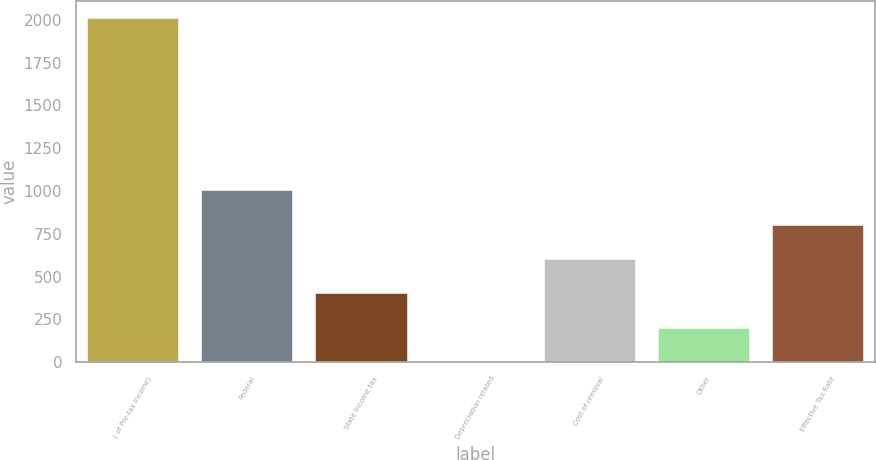Convert chart to OTSL. <chart><loc_0><loc_0><loc_500><loc_500><bar_chart><fcel>( of Pre-tax income)<fcel>Federal<fcel>State income tax<fcel>Depreciation related<fcel>Cost of removal<fcel>Other<fcel>Effective Tax Rate<nl><fcel>2008<fcel>1004.5<fcel>402.4<fcel>1<fcel>603.1<fcel>201.7<fcel>803.8<nl></chart> 